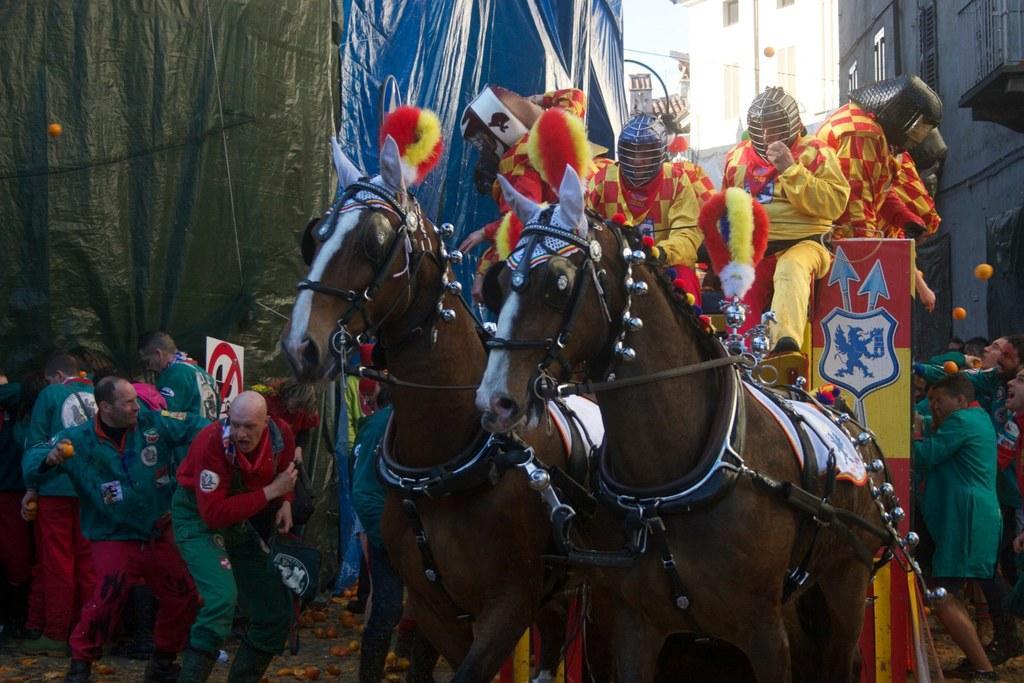How would you summarize this image in a sentence or two? This picture taken in the outside. There is a group of people who are riding the horses and left side of the horses there are group of people who are in red and green shirt and there is a sign board and these is a cover. Background of the group of people is a building. 